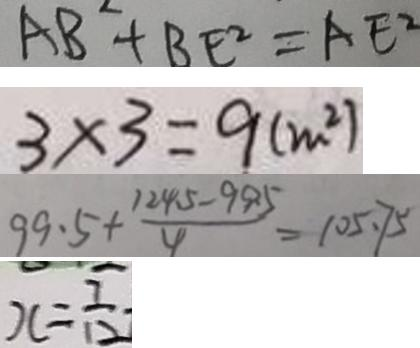<formula> <loc_0><loc_0><loc_500><loc_500>A B + B E ^ { 2 } = A E ^ { 2 } 
 3 \times 3 = 9 ( m ^ { 2 } ) 
 9 9 . 5 + \frac { 1 2 4 . 5 - 9 9 . 5 } { 4 } = 1 0 5 . 7 5 
 x = \frac { 7 } { 1 2 }</formula> 